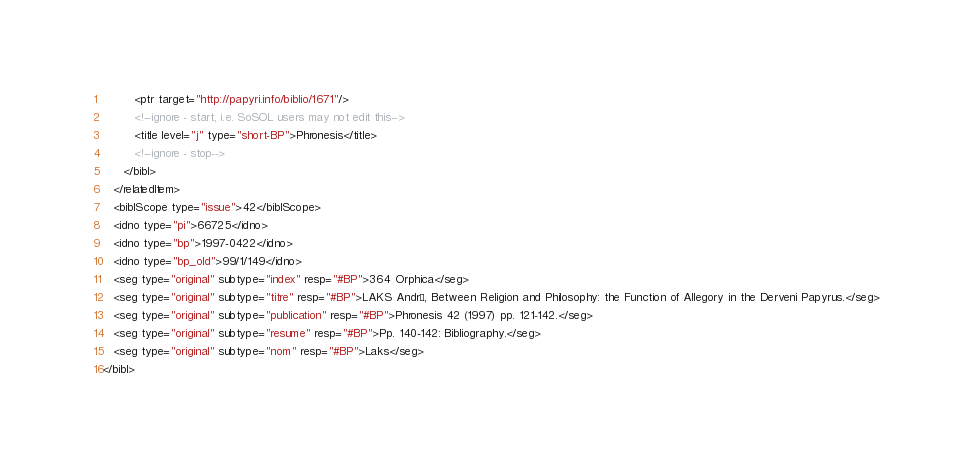<code> <loc_0><loc_0><loc_500><loc_500><_XML_>         <ptr target="http://papyri.info/biblio/1671"/>
         <!--ignore - start, i.e. SoSOL users may not edit this-->
         <title level="j" type="short-BP">Phronesis</title>
         <!--ignore - stop-->
      </bibl>
   </relatedItem>
   <biblScope type="issue">42</biblScope>
   <idno type="pi">66725</idno>
   <idno type="bp">1997-0422</idno>
   <idno type="bp_old">99/1/149</idno>
   <seg type="original" subtype="index" resp="#BP">364 Orphica</seg>
   <seg type="original" subtype="titre" resp="#BP">LAKS André, Between Religion and Philosophy: the Function of Allegory in the Derveni Papyrus.</seg>
   <seg type="original" subtype="publication" resp="#BP">Phronesis 42 (1997) pp. 121-142.</seg>
   <seg type="original" subtype="resume" resp="#BP">Pp. 140-142: Bibliography.</seg>
   <seg type="original" subtype="nom" resp="#BP">Laks</seg>
</bibl>
</code> 